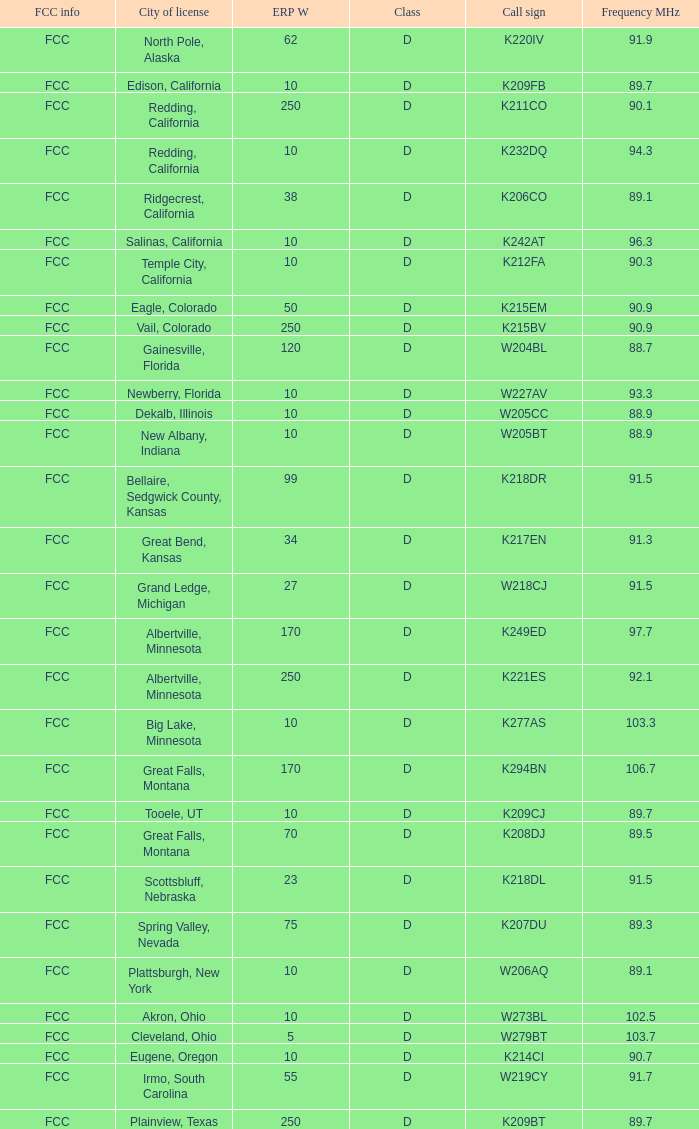What is the FCC info of the translator with an Irmo, South Carolina city license? FCC. 